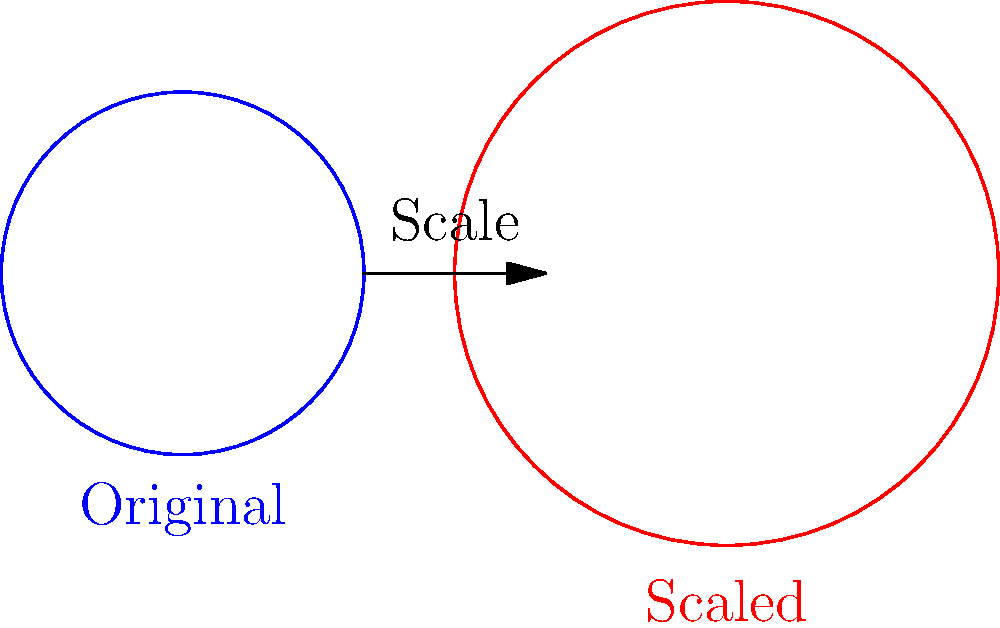A tandoor oven with a radius of 50 cm is scaled up by a factor of 1.5. How does this scaling affect the cooking capacity (in terms of surface area) of the tandoor? Let's approach this step-by-step:

1) The original tandoor has a radius of 50 cm.

2) The surface area of a circular base is given by the formula $A = \pi r^2$.

3) For the original tandoor:
   $A_1 = \pi (50 \text{ cm})^2 = 7,853.98 \text{ cm}^2$

4) The scaling factor is 1.5, so the new radius is:
   $50 \text{ cm} \times 1.5 = 75 \text{ cm}$

5) For the scaled tandoor:
   $A_2 = \pi (75 \text{ cm})^2 = 17,671.46 \text{ cm}^2$

6) To find the factor by which the cooking capacity increased, we divide the new area by the original area:

   $\frac{A_2}{A_1} = \frac{17,671.46}{7,853.98} = 2.25$

7) This means the cooking capacity has increased by a factor of 2.25, or 125%.

8) We can verify this mathematically:
   $(1.5)^2 = 2.25$

   This is because area scales with the square of the linear dimensions.
Answer: The cooking capacity increases by a factor of 2.25 or 125%. 